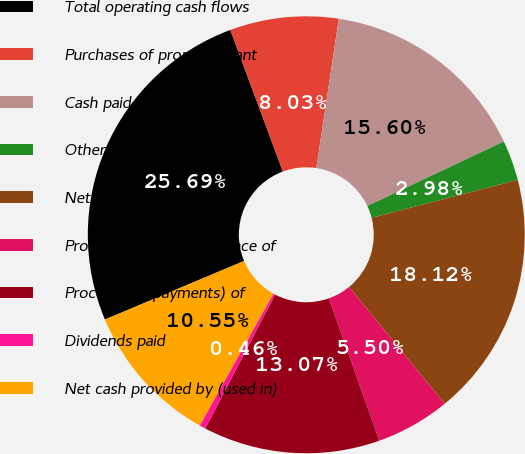<chart> <loc_0><loc_0><loc_500><loc_500><pie_chart><fcel>Total operating cash flows<fcel>Purchases of property plant<fcel>Cash paid for acquisitions<fcel>Other sources<fcel>Net cash used in investing<fcel>Proceeds from the issuance of<fcel>Proceeds (repayments) of<fcel>Dividends paid<fcel>Net cash provided by (used in)<nl><fcel>25.69%<fcel>8.03%<fcel>15.6%<fcel>2.98%<fcel>18.12%<fcel>5.5%<fcel>13.07%<fcel>0.46%<fcel>10.55%<nl></chart> 